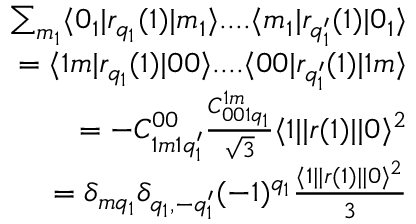<formula> <loc_0><loc_0><loc_500><loc_500>\begin{array} { r } { \sum _ { m _ { 1 } } \langle 0 _ { 1 } | r _ { q _ { 1 } } ( 1 ) | m _ { 1 } \rangle \cdots \langle m _ { 1 } | r _ { q _ { 1 } ^ { \prime } } ( 1 ) | 0 _ { 1 } \rangle } \\ { = \langle 1 m | r _ { q _ { 1 } } ( 1 ) | 0 0 \rangle \cdots \langle 0 0 | r _ { q _ { 1 } ^ { \prime } } ( 1 ) | 1 m \rangle } \\ { = - C _ { 1 m 1 q _ { 1 } ^ { \prime } } ^ { 0 0 } \frac { C _ { 0 0 1 q _ { 1 } } ^ { 1 m } } { \sqrt { 3 } } \langle 1 | | r ( 1 ) | | 0 \rangle ^ { 2 } } \\ { = \delta _ { m q _ { 1 } } \delta _ { q _ { 1 } , - q _ { 1 } ^ { \prime } } ( - 1 ) ^ { q _ { 1 } } \frac { \langle 1 | | r ( 1 ) | | 0 \rangle ^ { 2 } } { 3 } } \end{array}</formula> 